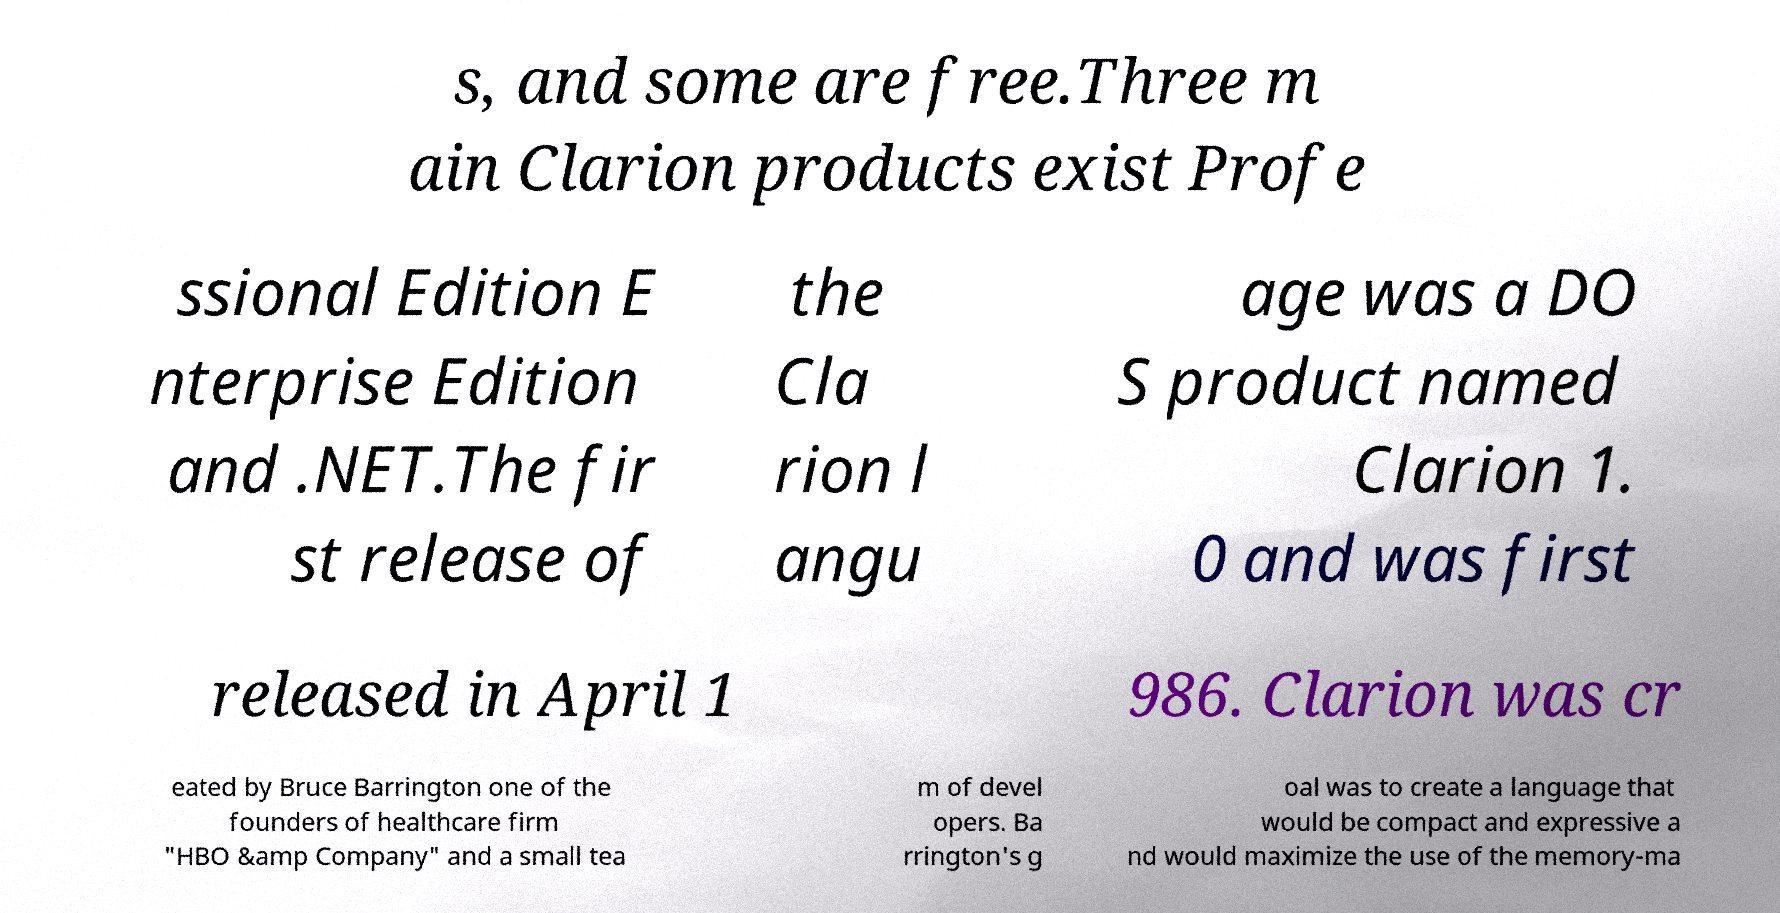Could you assist in decoding the text presented in this image and type it out clearly? s, and some are free.Three m ain Clarion products exist Profe ssional Edition E nterprise Edition and .NET.The fir st release of the Cla rion l angu age was a DO S product named Clarion 1. 0 and was first released in April 1 986. Clarion was cr eated by Bruce Barrington one of the founders of healthcare firm "HBO &amp Company" and a small tea m of devel opers. Ba rrington's g oal was to create a language that would be compact and expressive a nd would maximize the use of the memory-ma 